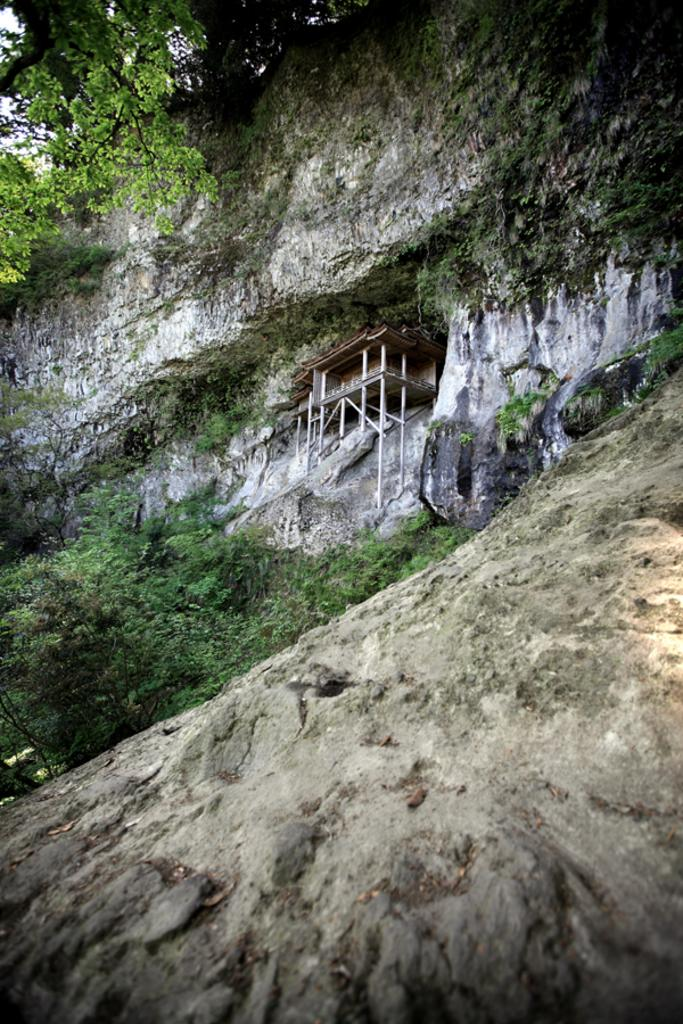What type of vegetation can be seen in the image? There are trees in the image. What type of structure is present in the image? There is a house in the image. On what surface is the house situated? The house is on a rock. How many bats are hanging from the trees in the image? There are no bats present in the image; only trees and a house can be seen. What type of conversation is taking place between the trees in the image? Trees do not engage in conversation, so there is no talk between the trees in the image. 